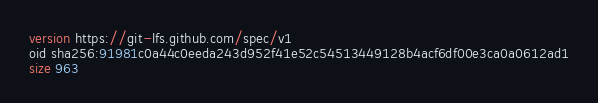<code> <loc_0><loc_0><loc_500><loc_500><_SQL_>version https://git-lfs.github.com/spec/v1
oid sha256:91981c0a44c0eeda243d952f41e52c54513449128b4acf6df00e3ca0a0612ad1
size 963
</code> 